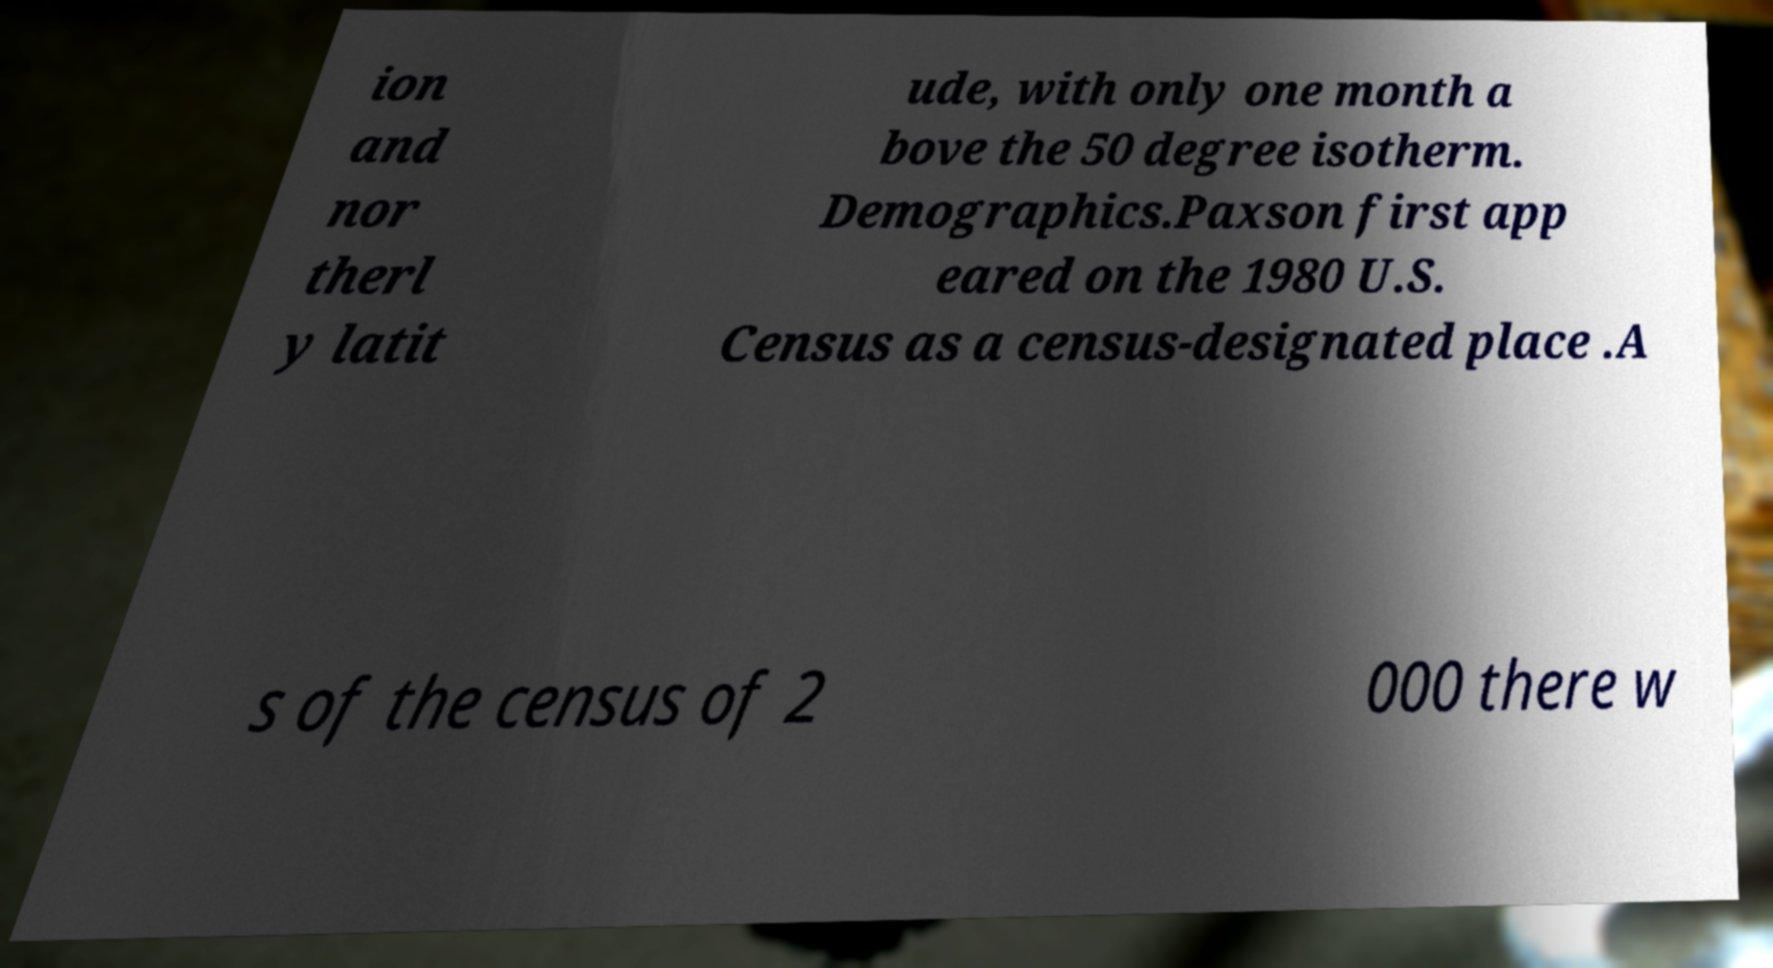Could you assist in decoding the text presented in this image and type it out clearly? ion and nor therl y latit ude, with only one month a bove the 50 degree isotherm. Demographics.Paxson first app eared on the 1980 U.S. Census as a census-designated place .A s of the census of 2 000 there w 